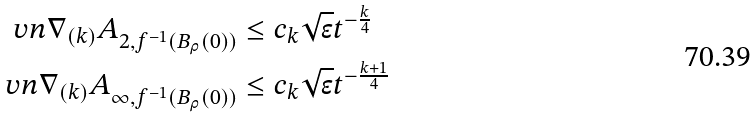<formula> <loc_0><loc_0><loc_500><loc_500>\ v n { \nabla _ { ( k ) } A } _ { 2 , f ^ { - 1 } ( B _ { \rho } ( 0 ) ) } & \leq c _ { k } \sqrt { \epsilon } t ^ { - \frac { k } { 4 } } \\ \ v n { \nabla _ { ( k ) } A } _ { \infty , f ^ { - 1 } ( B _ { \rho } ( 0 ) ) } & \leq c _ { k } \sqrt { \epsilon } t ^ { - \frac { k + 1 } { 4 } }</formula> 